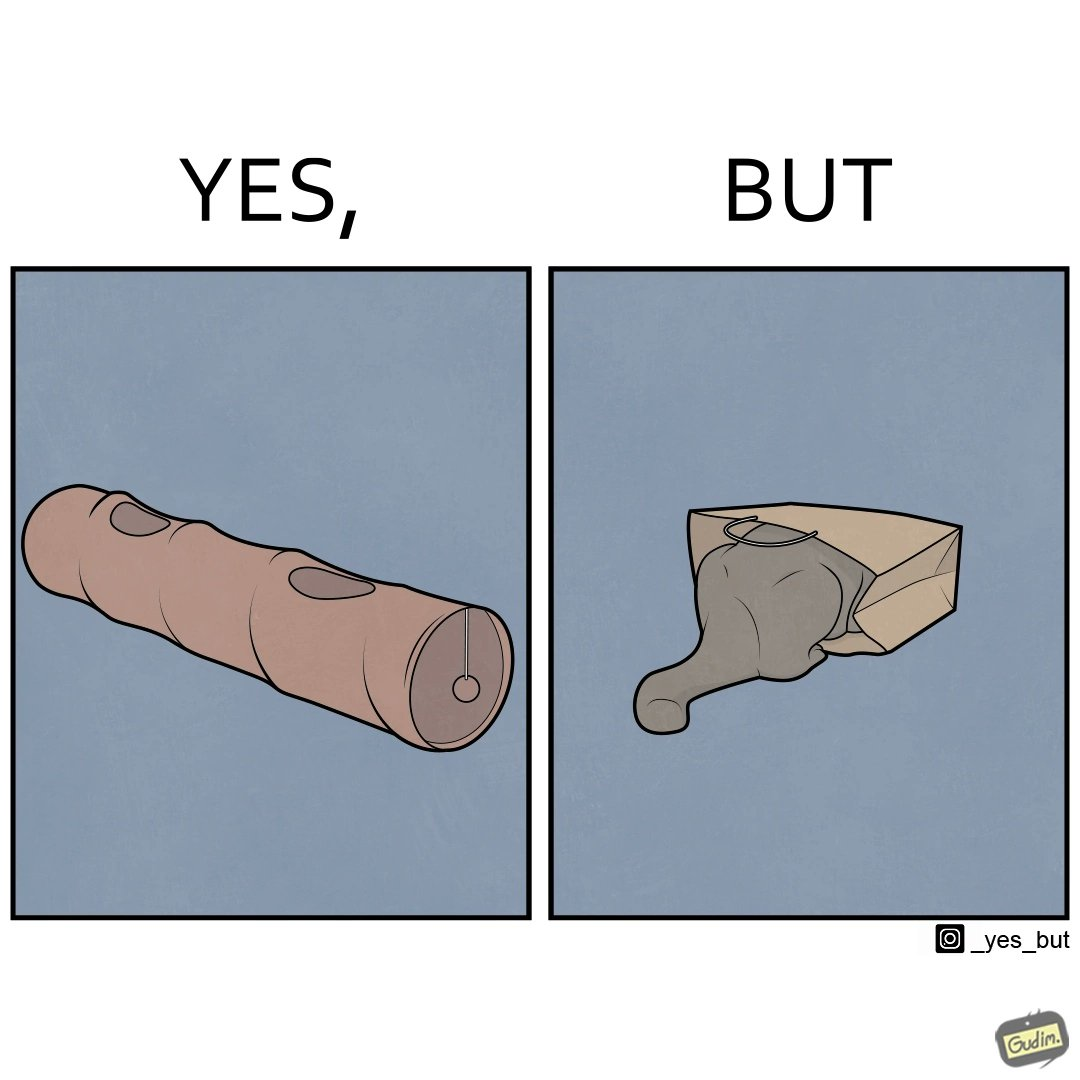Describe the satirical element in this image. The image is funny, because even when there is a dedicated thing for the animal to play with it still is hiding itself in the paper bag 